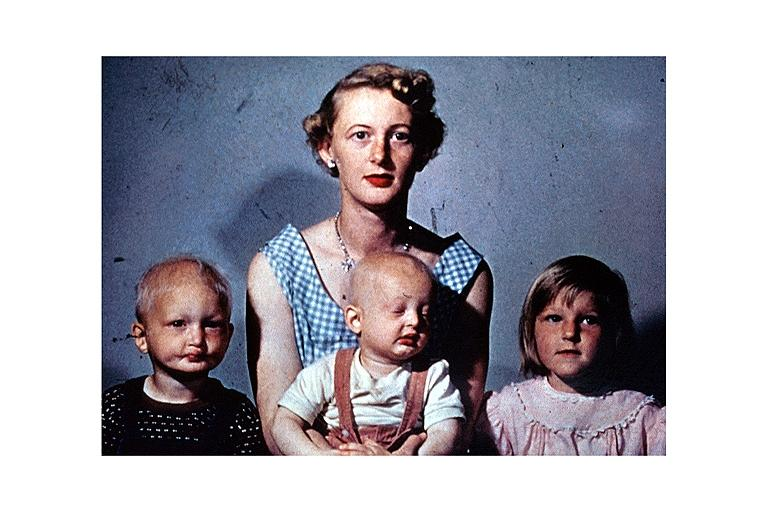what does this image show?
Answer the question using a single word or phrase. Anhidrotic ectodermal dysplasia 